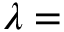Convert formula to latex. <formula><loc_0><loc_0><loc_500><loc_500>\lambda =</formula> 